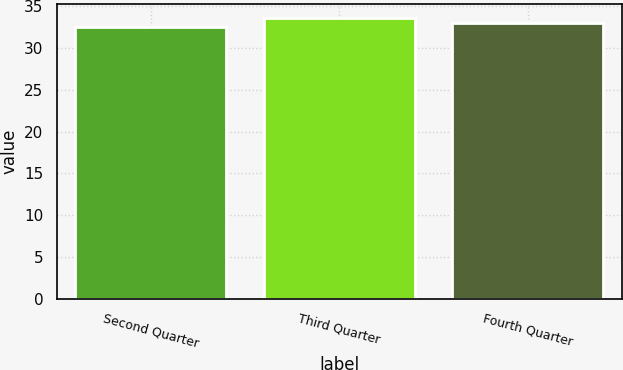<chart> <loc_0><loc_0><loc_500><loc_500><bar_chart><fcel>Second Quarter<fcel>Third Quarter<fcel>Fourth Quarter<nl><fcel>32.5<fcel>33.58<fcel>33<nl></chart> 